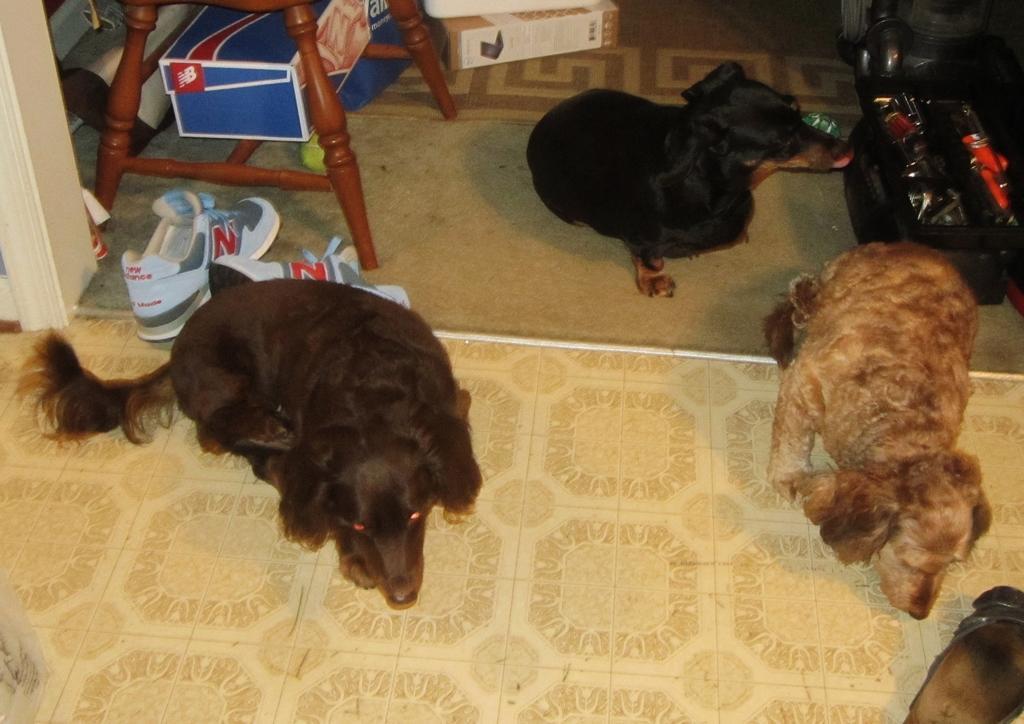How would you summarize this image in a sentence or two? In this image we can see some dogs on the floor. On the left side of the image we can see a box placed in a wooden frame, a ball and shoes placed on the floor. At the right side of the image we can see some objects in a container. At the top of the image we can see some boxes placed on the ground. 